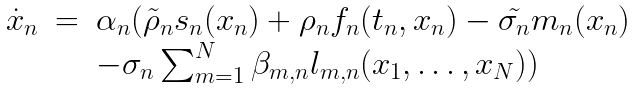Convert formula to latex. <formula><loc_0><loc_0><loc_500><loc_500>\begin{array} { r c l } \dot { x } _ { n } & = & \alpha _ { n } ( \tilde { \rho } _ { n } s _ { n } ( x _ { n } ) + \rho _ { n } f _ { n } ( t _ { n } , x _ { n } ) - \tilde { \sigma _ { n } } m _ { n } ( x _ { n } ) \\ & & - \sigma _ { n } \sum _ { m = 1 } ^ { N } \beta _ { m , n } l _ { m , n } ( x _ { 1 } , \dots , x _ { N } ) ) \end{array}</formula> 